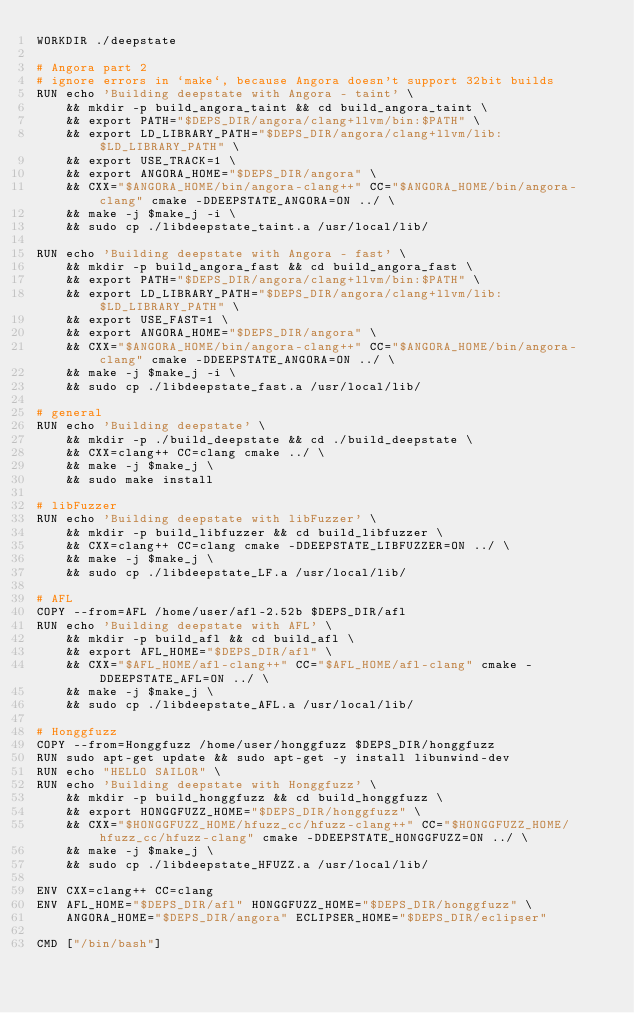Convert code to text. <code><loc_0><loc_0><loc_500><loc_500><_Dockerfile_>WORKDIR ./deepstate

# Angora part 2
# ignore errors in `make`, because Angora doesn't support 32bit builds
RUN echo 'Building deepstate with Angora - taint' \
    && mkdir -p build_angora_taint && cd build_angora_taint \
    && export PATH="$DEPS_DIR/angora/clang+llvm/bin:$PATH" \
    && export LD_LIBRARY_PATH="$DEPS_DIR/angora/clang+llvm/lib:$LD_LIBRARY_PATH" \
    && export USE_TRACK=1 \
    && export ANGORA_HOME="$DEPS_DIR/angora" \
    && CXX="$ANGORA_HOME/bin/angora-clang++" CC="$ANGORA_HOME/bin/angora-clang" cmake -DDEEPSTATE_ANGORA=ON ../ \
    && make -j $make_j -i \
    && sudo cp ./libdeepstate_taint.a /usr/local/lib/

RUN echo 'Building deepstate with Angora - fast' \
    && mkdir -p build_angora_fast && cd build_angora_fast \
    && export PATH="$DEPS_DIR/angora/clang+llvm/bin:$PATH" \
    && export LD_LIBRARY_PATH="$DEPS_DIR/angora/clang+llvm/lib:$LD_LIBRARY_PATH" \
    && export USE_FAST=1 \
    && export ANGORA_HOME="$DEPS_DIR/angora" \
    && CXX="$ANGORA_HOME/bin/angora-clang++" CC="$ANGORA_HOME/bin/angora-clang" cmake -DDEEPSTATE_ANGORA=ON ../ \
    && make -j $make_j -i \
    && sudo cp ./libdeepstate_fast.a /usr/local/lib/

# general
RUN echo 'Building deepstate' \
    && mkdir -p ./build_deepstate && cd ./build_deepstate \
    && CXX=clang++ CC=clang cmake ../ \
    && make -j $make_j \
    && sudo make install

# libFuzzer
RUN echo 'Building deepstate with libFuzzer' \
    && mkdir -p build_libfuzzer && cd build_libfuzzer \
    && CXX=clang++ CC=clang cmake -DDEEPSTATE_LIBFUZZER=ON ../ \
    && make -j $make_j \
    && sudo cp ./libdeepstate_LF.a /usr/local/lib/

# AFL
COPY --from=AFL /home/user/afl-2.52b $DEPS_DIR/afl
RUN echo 'Building deepstate with AFL' \
    && mkdir -p build_afl && cd build_afl \
    && export AFL_HOME="$DEPS_DIR/afl" \
    && CXX="$AFL_HOME/afl-clang++" CC="$AFL_HOME/afl-clang" cmake -DDEEPSTATE_AFL=ON ../ \
    && make -j $make_j \
    && sudo cp ./libdeepstate_AFL.a /usr/local/lib/

# Honggfuzz
COPY --from=Honggfuzz /home/user/honggfuzz $DEPS_DIR/honggfuzz
RUN sudo apt-get update && sudo apt-get -y install libunwind-dev
RUN echo "HELLO SAILOR" \
RUN echo 'Building deepstate with Honggfuzz' \
    && mkdir -p build_honggfuzz && cd build_honggfuzz \
    && export HONGGFUZZ_HOME="$DEPS_DIR/honggfuzz" \
    && CXX="$HONGGFUZZ_HOME/hfuzz_cc/hfuzz-clang++" CC="$HONGGFUZZ_HOME/hfuzz_cc/hfuzz-clang" cmake -DDEEPSTATE_HONGGFUZZ=ON ../ \
    && make -j $make_j \
    && sudo cp ./libdeepstate_HFUZZ.a /usr/local/lib/

ENV CXX=clang++ CC=clang
ENV AFL_HOME="$DEPS_DIR/afl" HONGGFUZZ_HOME="$DEPS_DIR/honggfuzz" \
    ANGORA_HOME="$DEPS_DIR/angora" ECLIPSER_HOME="$DEPS_DIR/eclipser"

CMD ["/bin/bash"]</code> 